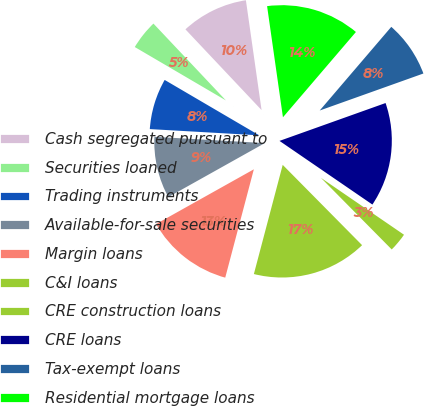Convert chart. <chart><loc_0><loc_0><loc_500><loc_500><pie_chart><fcel>Cash segregated pursuant to<fcel>Securities loaned<fcel>Trading instruments<fcel>Available-for-sale securities<fcel>Margin loans<fcel>C&I loans<fcel>CRE construction loans<fcel>CRE loans<fcel>Tax-exempt loans<fcel>Residential mortgage loans<nl><fcel>9.78%<fcel>4.53%<fcel>7.53%<fcel>9.03%<fcel>12.77%<fcel>16.52%<fcel>3.03%<fcel>15.02%<fcel>8.28%<fcel>13.52%<nl></chart> 